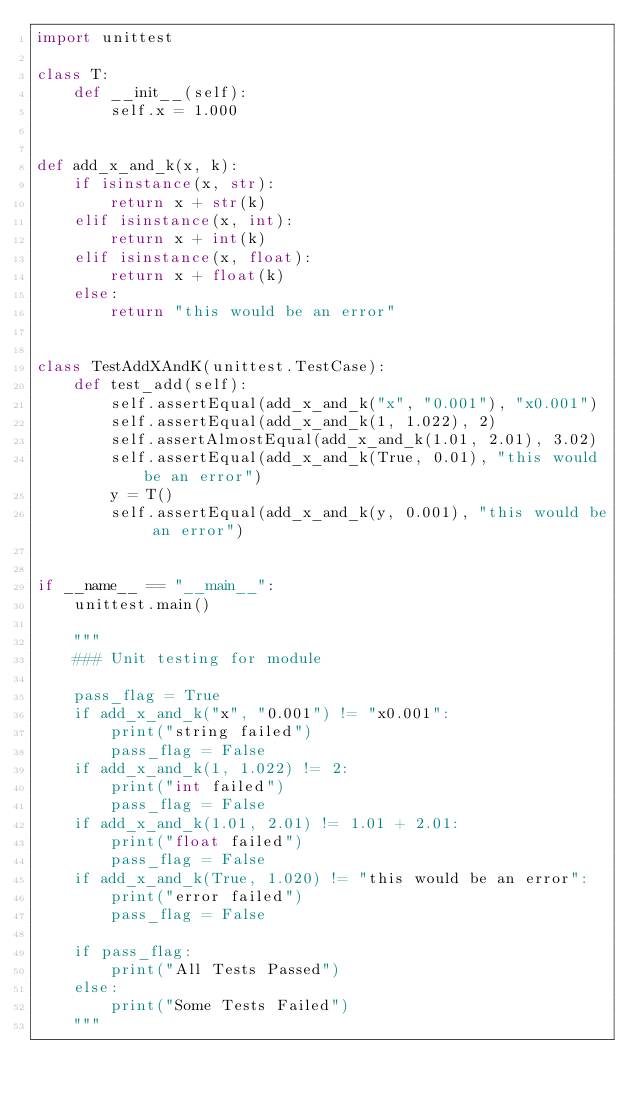Convert code to text. <code><loc_0><loc_0><loc_500><loc_500><_Python_>import unittest

class T:
    def __init__(self):
        self.x = 1.000


def add_x_and_k(x, k):
    if isinstance(x, str):
        return x + str(k)
    elif isinstance(x, int):
        return x + int(k)
    elif isinstance(x, float):
        return x + float(k)
    else:
        return "this would be an error"


class TestAddXAndK(unittest.TestCase):
    def test_add(self):
        self.assertEqual(add_x_and_k("x", "0.001"), "x0.001")
        self.assertEqual(add_x_and_k(1, 1.022), 2)
        self.assertAlmostEqual(add_x_and_k(1.01, 2.01), 3.02)
        self.assertEqual(add_x_and_k(True, 0.01), "this would be an error")
        y = T()
        self.assertEqual(add_x_and_k(y, 0.001), "this would be an error")


if __name__ == "__main__":
    unittest.main()

    """
    ### Unit testing for module

    pass_flag = True
    if add_x_and_k("x", "0.001") != "x0.001":
        print("string failed")
        pass_flag = False
    if add_x_and_k(1, 1.022) != 2:
        print("int failed")
        pass_flag = False
    if add_x_and_k(1.01, 2.01) != 1.01 + 2.01:
        print("float failed")
        pass_flag = False
    if add_x_and_k(True, 1.020) != "this would be an error":
        print("error failed")
        pass_flag = False

    if pass_flag:
        print("All Tests Passed")
    else:
        print("Some Tests Failed")
    """
</code> 